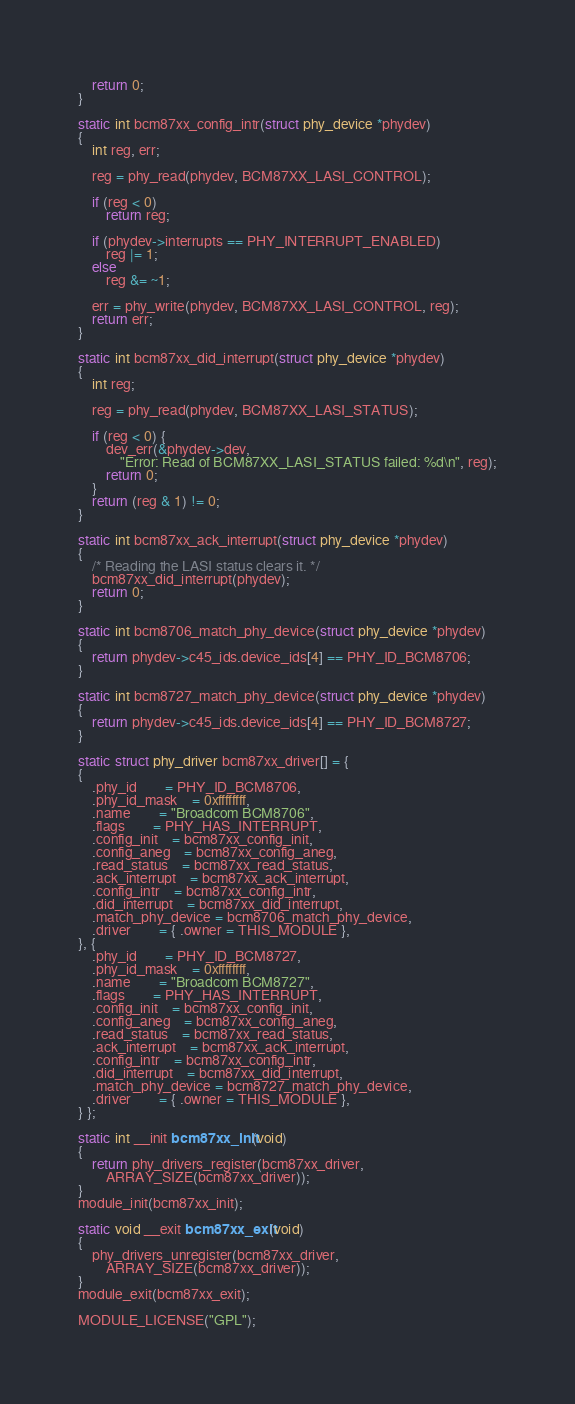<code> <loc_0><loc_0><loc_500><loc_500><_C_>	return 0;
}

static int bcm87xx_config_intr(struct phy_device *phydev)
{
	int reg, err;

	reg = phy_read(phydev, BCM87XX_LASI_CONTROL);

	if (reg < 0)
		return reg;

	if (phydev->interrupts == PHY_INTERRUPT_ENABLED)
		reg |= 1;
	else
		reg &= ~1;

	err = phy_write(phydev, BCM87XX_LASI_CONTROL, reg);
	return err;
}

static int bcm87xx_did_interrupt(struct phy_device *phydev)
{
	int reg;

	reg = phy_read(phydev, BCM87XX_LASI_STATUS);

	if (reg < 0) {
		dev_err(&phydev->dev,
			"Error: Read of BCM87XX_LASI_STATUS failed: %d\n", reg);
		return 0;
	}
	return (reg & 1) != 0;
}

static int bcm87xx_ack_interrupt(struct phy_device *phydev)
{
	/* Reading the LASI status clears it. */
	bcm87xx_did_interrupt(phydev);
	return 0;
}

static int bcm8706_match_phy_device(struct phy_device *phydev)
{
	return phydev->c45_ids.device_ids[4] == PHY_ID_BCM8706;
}

static int bcm8727_match_phy_device(struct phy_device *phydev)
{
	return phydev->c45_ids.device_ids[4] == PHY_ID_BCM8727;
}

static struct phy_driver bcm87xx_driver[] = {
{
	.phy_id		= PHY_ID_BCM8706,
	.phy_id_mask	= 0xffffffff,
	.name		= "Broadcom BCM8706",
	.flags		= PHY_HAS_INTERRUPT,
	.config_init	= bcm87xx_config_init,
	.config_aneg	= bcm87xx_config_aneg,
	.read_status	= bcm87xx_read_status,
	.ack_interrupt	= bcm87xx_ack_interrupt,
	.config_intr	= bcm87xx_config_intr,
	.did_interrupt	= bcm87xx_did_interrupt,
	.match_phy_device = bcm8706_match_phy_device,
	.driver		= { .owner = THIS_MODULE },
}, {
	.phy_id		= PHY_ID_BCM8727,
	.phy_id_mask	= 0xffffffff,
	.name		= "Broadcom BCM8727",
	.flags		= PHY_HAS_INTERRUPT,
	.config_init	= bcm87xx_config_init,
	.config_aneg	= bcm87xx_config_aneg,
	.read_status	= bcm87xx_read_status,
	.ack_interrupt	= bcm87xx_ack_interrupt,
	.config_intr	= bcm87xx_config_intr,
	.did_interrupt	= bcm87xx_did_interrupt,
	.match_phy_device = bcm8727_match_phy_device,
	.driver		= { .owner = THIS_MODULE },
} };

static int __init bcm87xx_init(void)
{
	return phy_drivers_register(bcm87xx_driver,
		ARRAY_SIZE(bcm87xx_driver));
}
module_init(bcm87xx_init);

static void __exit bcm87xx_exit(void)
{
	phy_drivers_unregister(bcm87xx_driver,
		ARRAY_SIZE(bcm87xx_driver));
}
module_exit(bcm87xx_exit);

MODULE_LICENSE("GPL");
</code> 